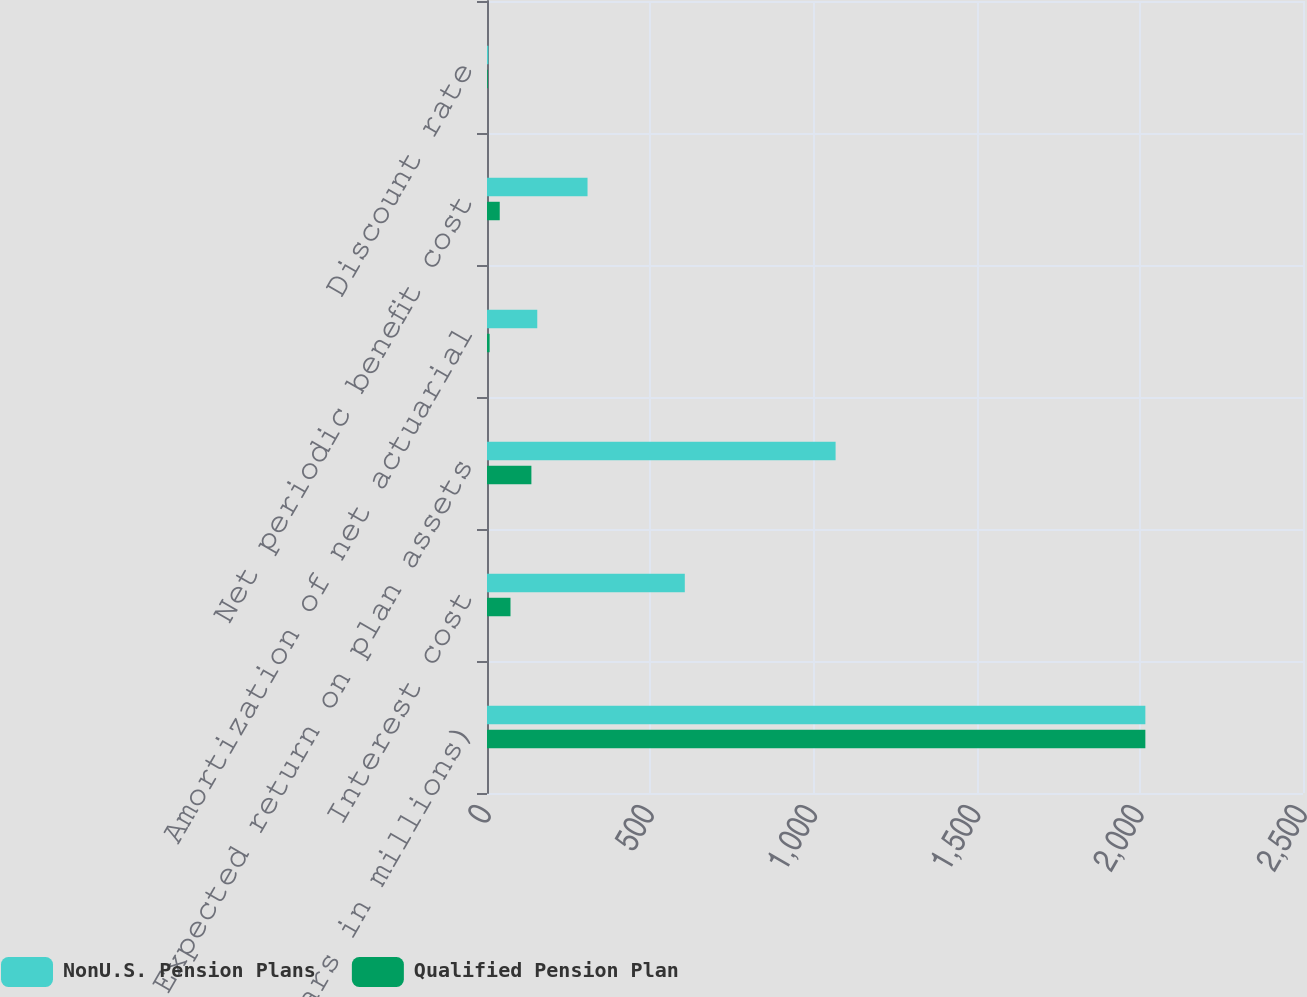Convert chart. <chart><loc_0><loc_0><loc_500><loc_500><stacked_bar_chart><ecel><fcel>(Dollars in millions)<fcel>Interest cost<fcel>Expected return on plan assets<fcel>Amortization of net actuarial<fcel>Net periodic benefit cost<fcel>Discount rate<nl><fcel>NonU.S. Pension Plans<fcel>2017<fcel>606<fcel>1068<fcel>154<fcel>308<fcel>4.16<nl><fcel>Qualified Pension Plan<fcel>2017<fcel>72<fcel>136<fcel>8<fcel>39<fcel>2.56<nl></chart> 